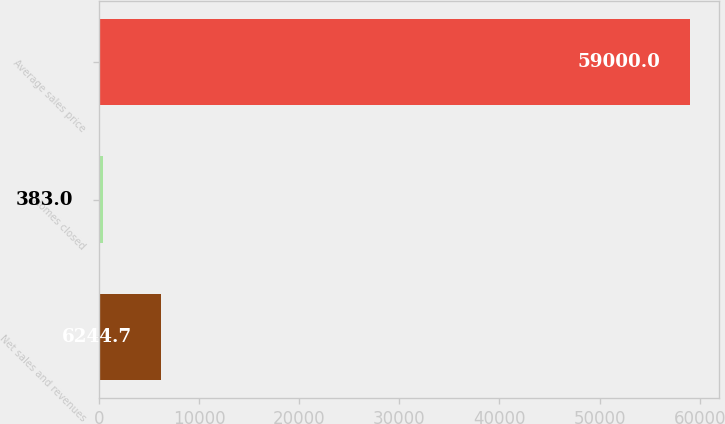Convert chart. <chart><loc_0><loc_0><loc_500><loc_500><bar_chart><fcel>Net sales and revenues<fcel>Homes closed<fcel>Average sales price<nl><fcel>6244.7<fcel>383<fcel>59000<nl></chart> 